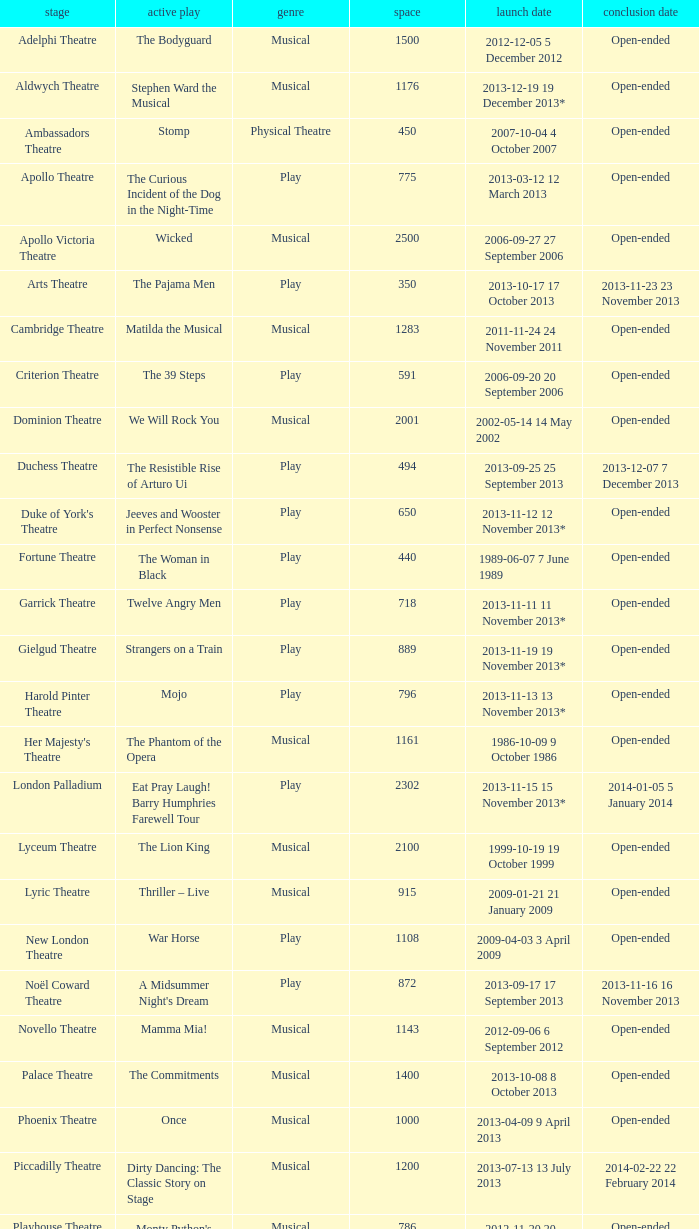What opening date has a capacity of 100? 2013-11-01 1 November 2013. 